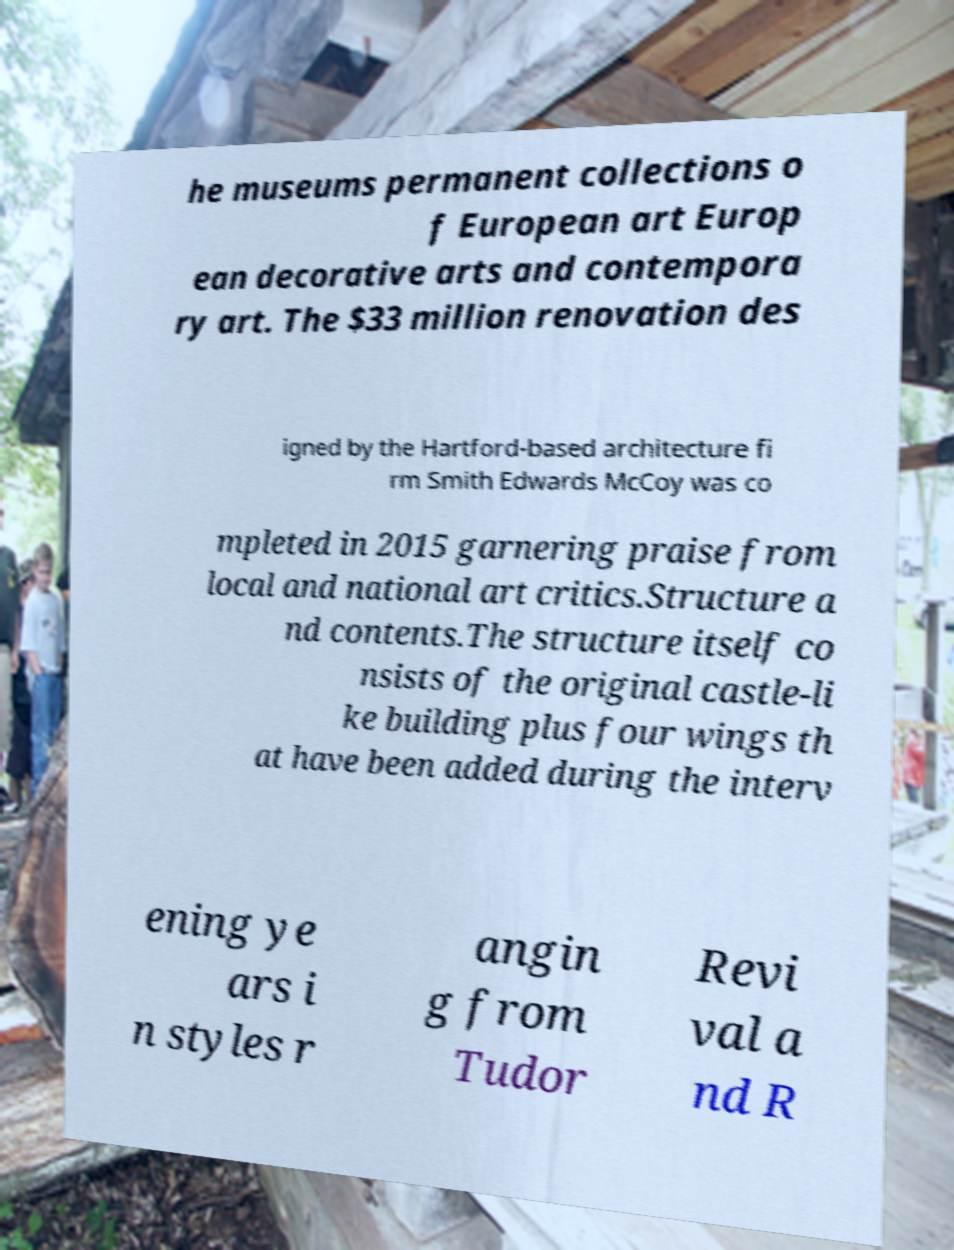Please read and relay the text visible in this image. What does it say? he museums permanent collections o f European art Europ ean decorative arts and contempora ry art. The $33 million renovation des igned by the Hartford-based architecture fi rm Smith Edwards McCoy was co mpleted in 2015 garnering praise from local and national art critics.Structure a nd contents.The structure itself co nsists of the original castle-li ke building plus four wings th at have been added during the interv ening ye ars i n styles r angin g from Tudor Revi val a nd R 